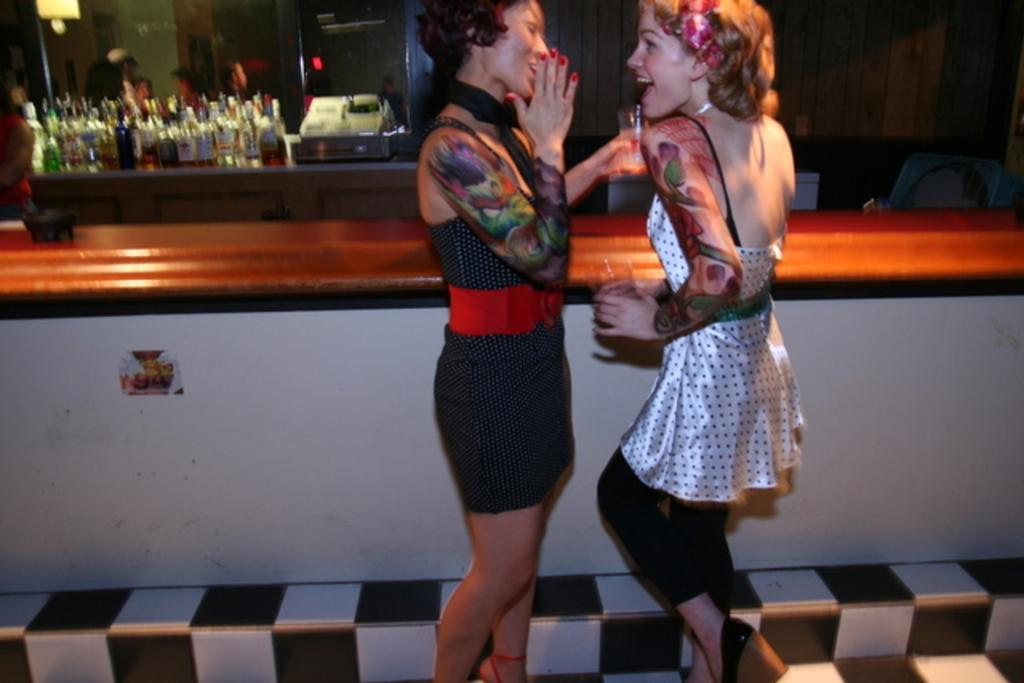How many women are in the image? There are two women in the image. What are the women doing in the image? The women are standing and holding glasses. What can be seen in the background of the image? There is a table, bottles, and a cupboard in the background of the image. What type of thread is being used to create the clouds in the image? There are no clouds present in the image, so there is no thread being used to create them. 